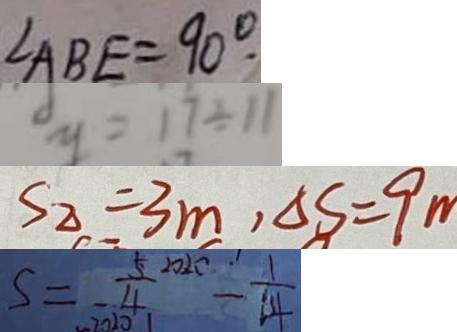Convert formula to latex. <formula><loc_0><loc_0><loc_500><loc_500>\angle A B E = 9 0 ^ { \circ } 
 y = 1 7 \div 1 1 
 S _ { \Delta } = 3 m , \Delta s = 9 m 
 S = \frac { 5 } { - 4 } ^ { 2 0 2 0 } - \frac { 1 } { 1 4 }</formula> 